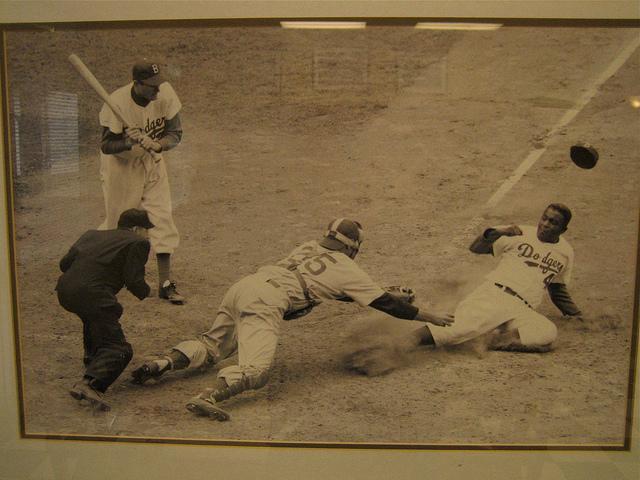How many people are in this photo?
Give a very brief answer. 4. How many people are shown?
Give a very brief answer. 4. How many people are there?
Give a very brief answer. 4. How many red cars do you see?
Give a very brief answer. 0. 